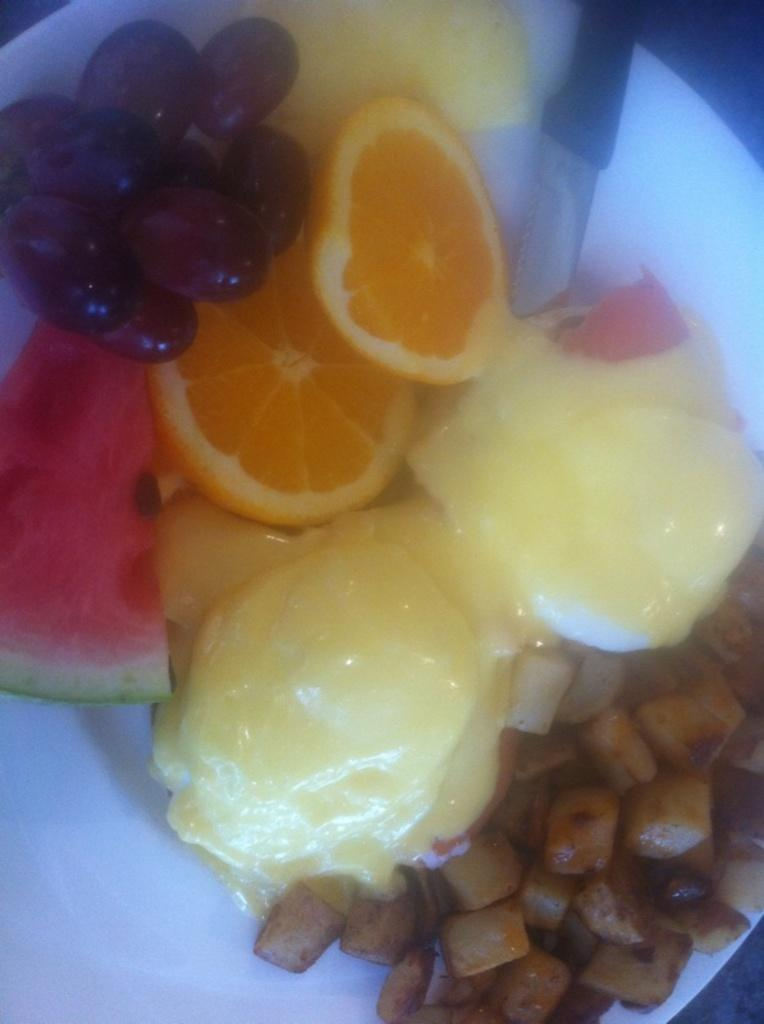What type of dessert is present in the image? There is ice cream in the image. What other food items can be seen in the image? There are fruits in the image. What utensil is visible in the image? There is a knife in the image. How are the ice cream, fruits, and knife arranged in the image? All the items (ice cream, fruits, and knife) are kept on a plate. What type of cloud is visible in the image? There is no cloud present in the image; it features ice cream, fruits, and a knife on a plate. How many copies of the plate are visible in the image? There is only one plate visible in the image, and it contains ice cream, fruits, and a knife. 